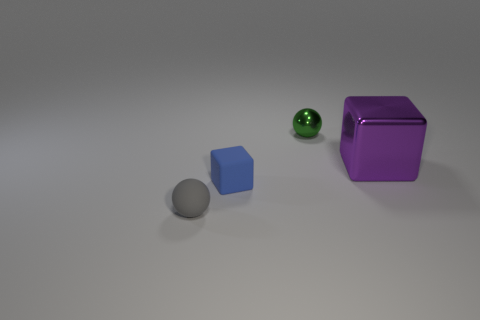Is there anything else that has the same size as the purple thing?
Give a very brief answer. No. What color is the small matte object that is in front of the blue rubber cube?
Your answer should be compact. Gray. There is a gray object that is the same material as the blue cube; what shape is it?
Provide a succinct answer. Sphere. Are there any other things that have the same color as the matte ball?
Give a very brief answer. No. Is the number of blue cubes to the left of the tiny green sphere greater than the number of big purple metal cubes in front of the tiny gray thing?
Offer a terse response. Yes. How many green objects have the same size as the green metal sphere?
Provide a succinct answer. 0. Are there fewer small green metal spheres on the right side of the green thing than tiny gray matte spheres that are to the left of the gray matte sphere?
Offer a terse response. No. Is there a tiny green metallic object that has the same shape as the large purple thing?
Keep it short and to the point. No. Do the small green metal object and the small blue rubber thing have the same shape?
Offer a very short reply. No. What number of large things are blue rubber balls or blue blocks?
Offer a terse response. 0. 